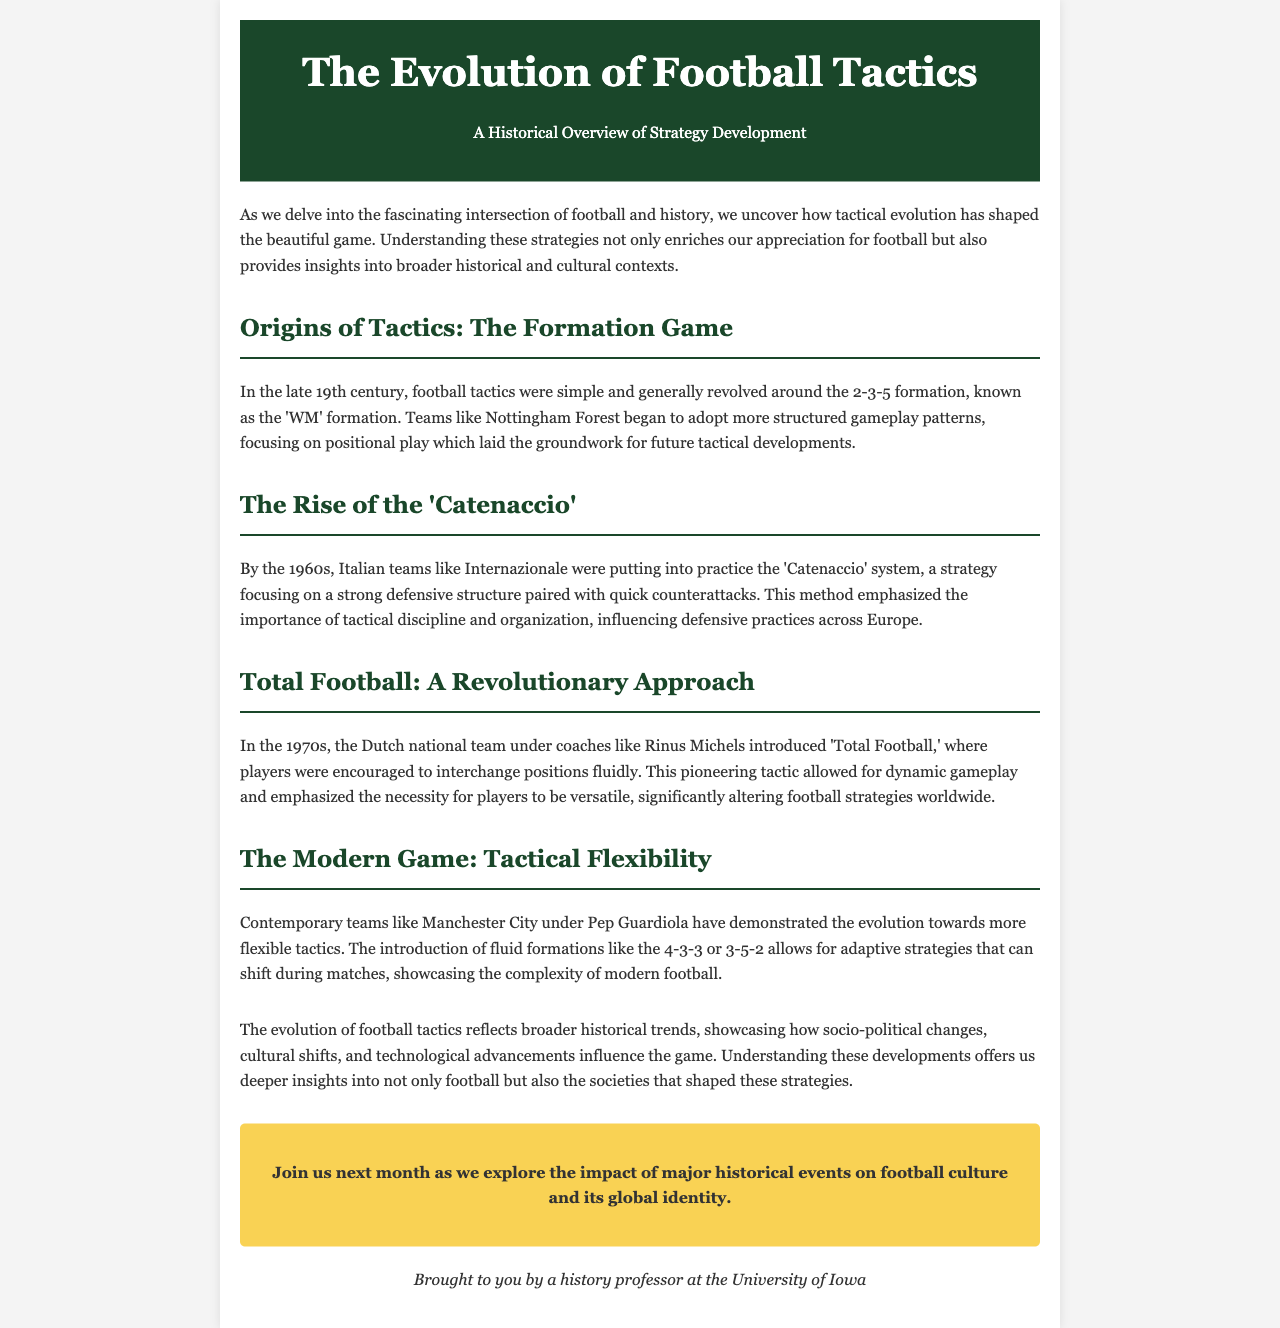what formation was common in the late 19th century? The document mentions that the common formation was the 2-3-5 formation, also referred to as the 'WM' formation.
Answer: 2-3-5 formation which Italian teams popularized the 'Catenaccio' system? The newsletter states that Italian teams like Internazionale implemented the 'Catenaccio' system during the 1960s.
Answer: Internazionale who was a key coach associated with 'Total Football'? The document references Rinus Michels as a pivotal coach for the Dutch national team promoting 'Total Football' in the 1970s.
Answer: Rinus Michels what is a flexible formation mentioned in contemporary football tactics? The newsletter indicates that modern teams utilize formations like 4-3-3 or 3-5-2 for flexible tactics.
Answer: 4-3-3 or 3-5-2 what does the evolution of football tactics reflect? The document suggests that the evolution mirrors broader historical trends including socio-political changes and cultural shifts.
Answer: broader historical trends how many sections are in the document discussing football tactics? The document includes five sections covering different tactical developments in football history.
Answer: five what is the primary focus of the newsletter? The document's main focus is on providing a historical overview of football strategy development and its evolution.
Answer: historical overview of strategy development when will the next newsletter explore football culture? The newsletter indicates that the next issue will delve into the impact of major historical events on football culture next month.
Answer: next month 